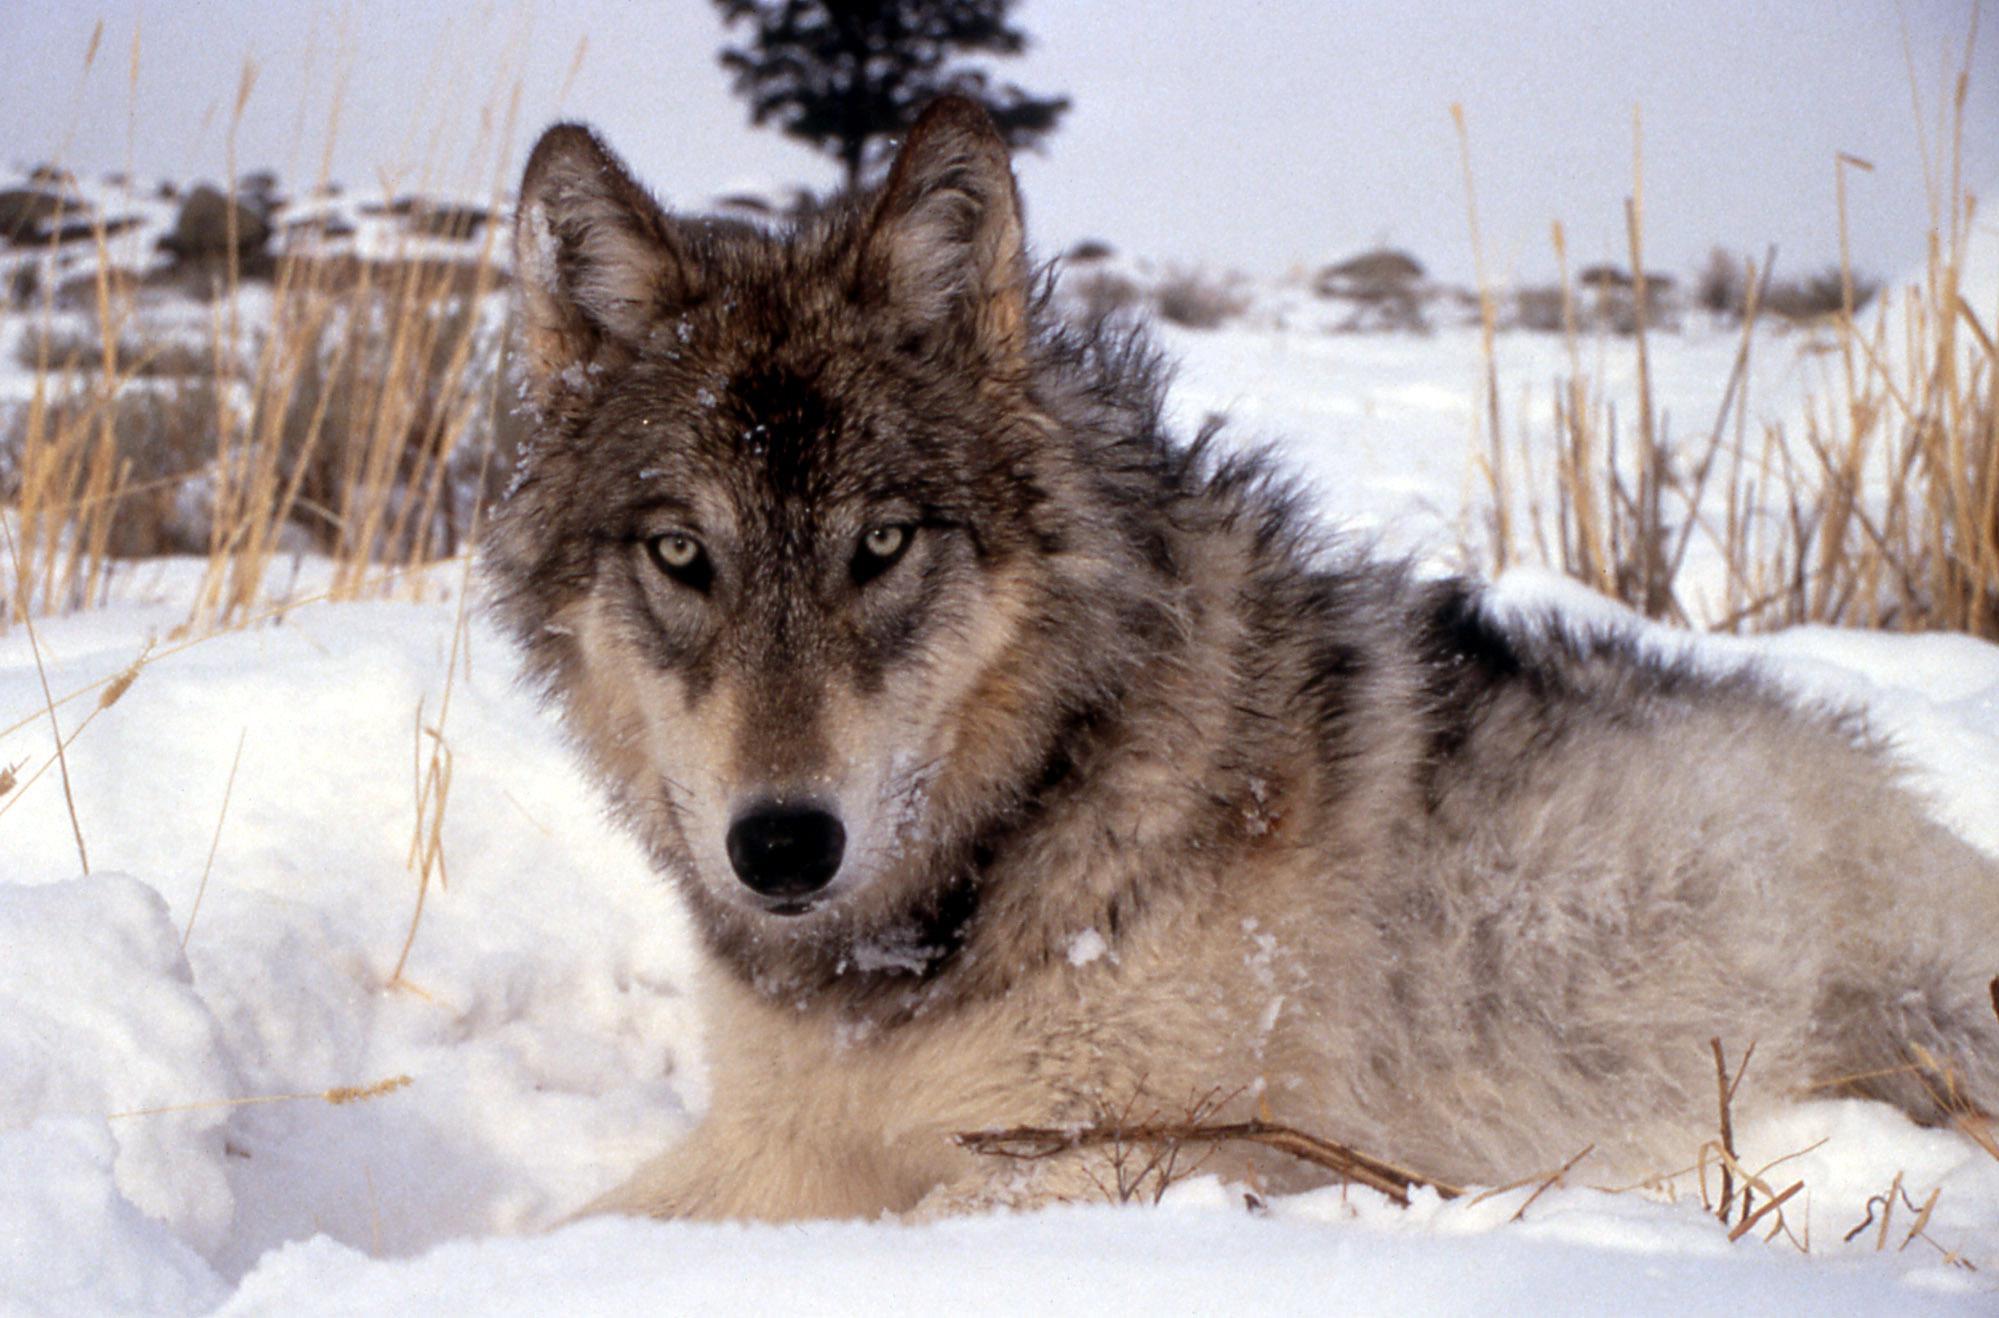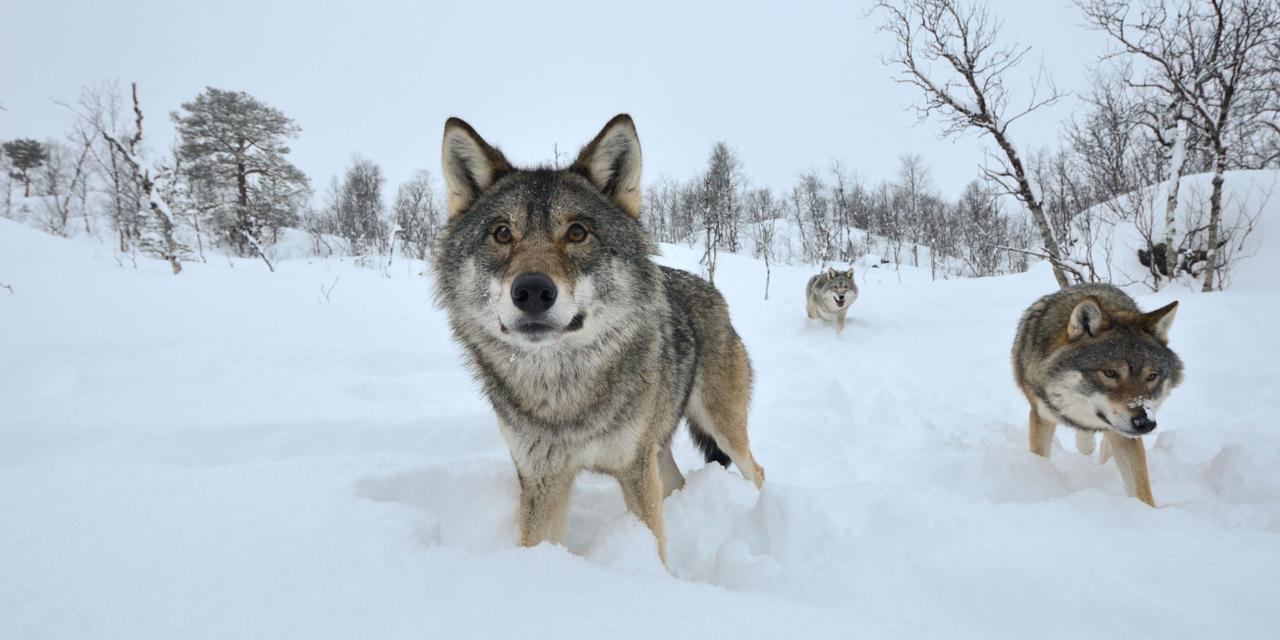The first image is the image on the left, the second image is the image on the right. Evaluate the accuracy of this statement regarding the images: "The left image shows a camera-gazing wolf with a bit of snow on its fur, and the right image contains two wolves in the foreground.". Is it true? Answer yes or no. Yes. 